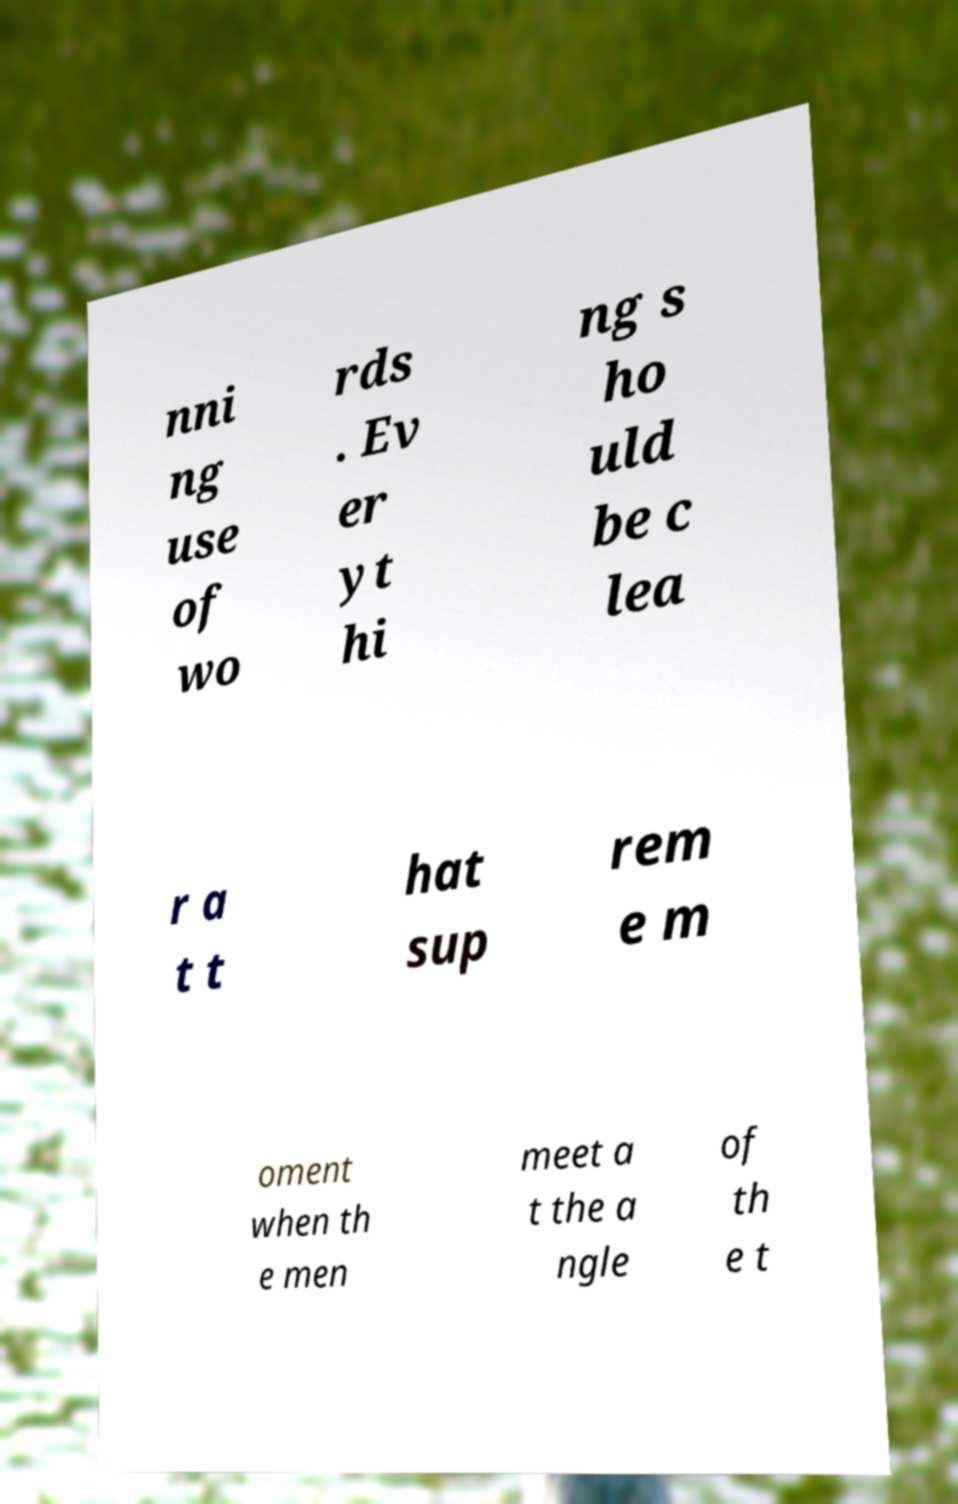Can you read and provide the text displayed in the image?This photo seems to have some interesting text. Can you extract and type it out for me? nni ng use of wo rds . Ev er yt hi ng s ho uld be c lea r a t t hat sup rem e m oment when th e men meet a t the a ngle of th e t 